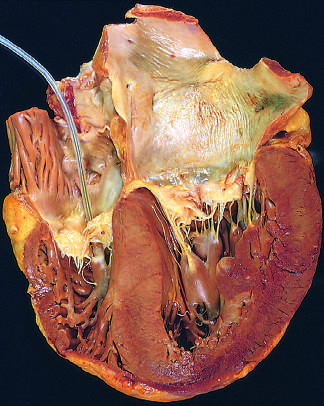what is concentric thickening of the left ventricular wall causing?
Answer the question using a single word or phrase. Reduction in lumen size 